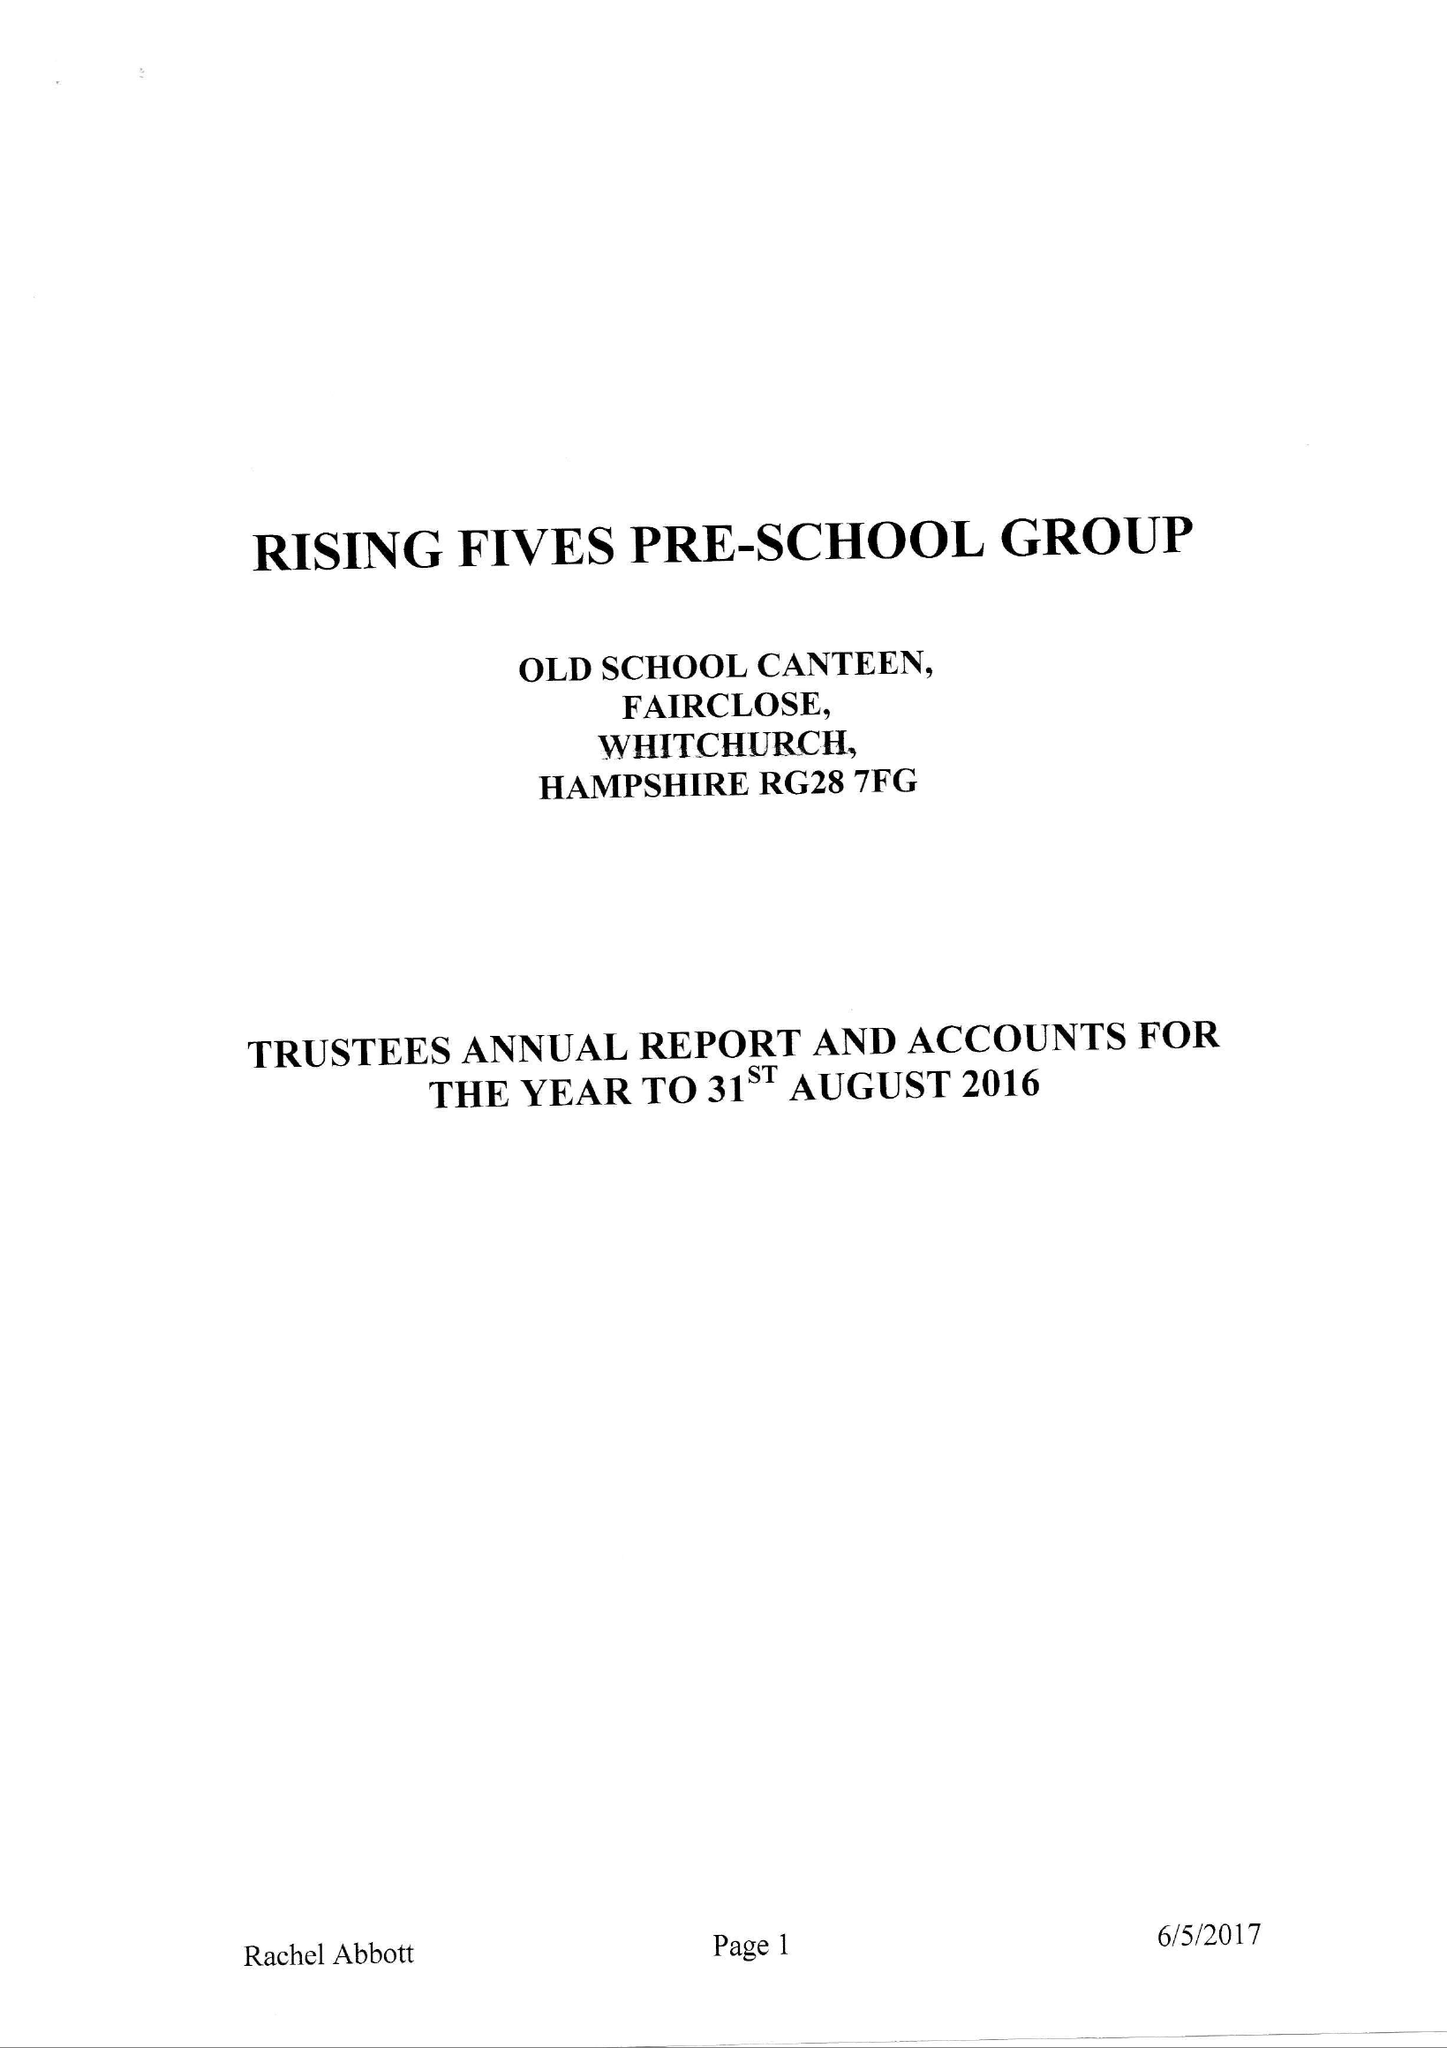What is the value for the charity_name?
Answer the question using a single word or phrase. Rising Fives Pre-School Group 